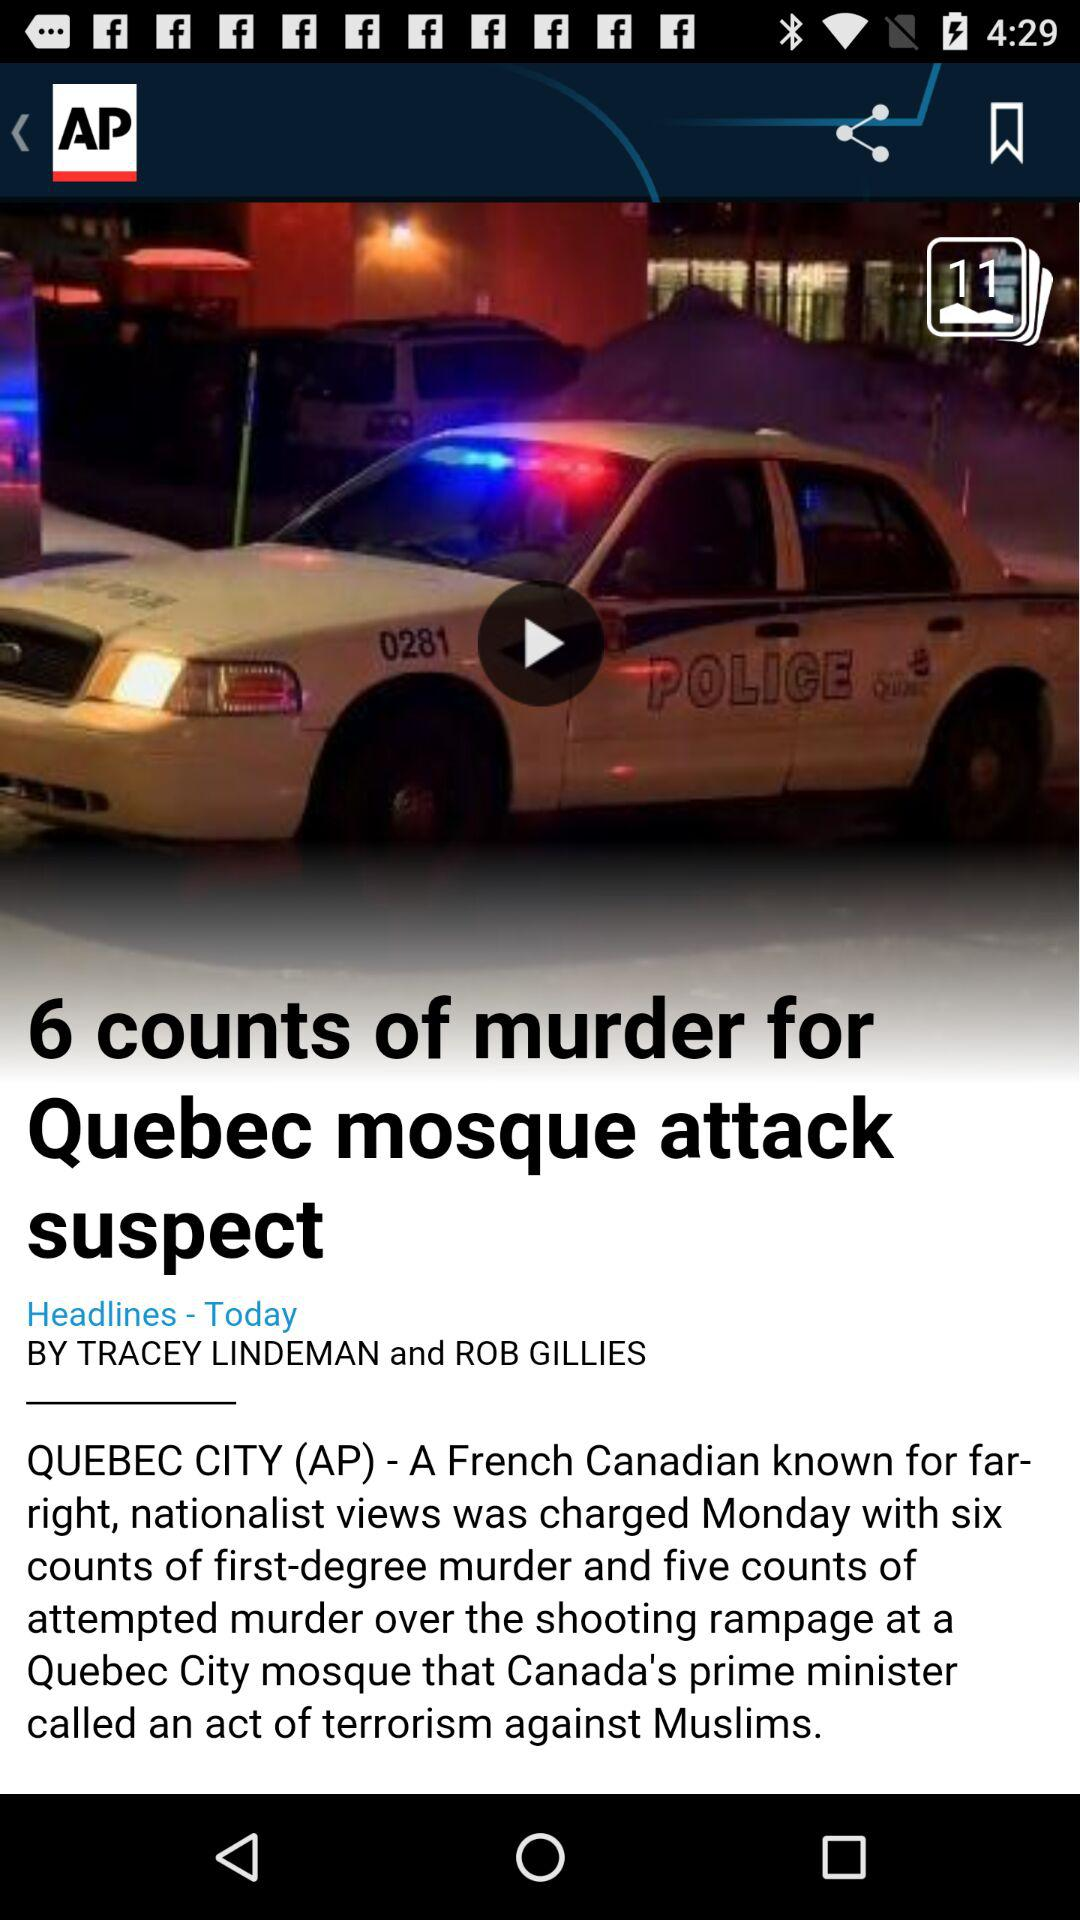What is the city name? The city name is Quebec City. 